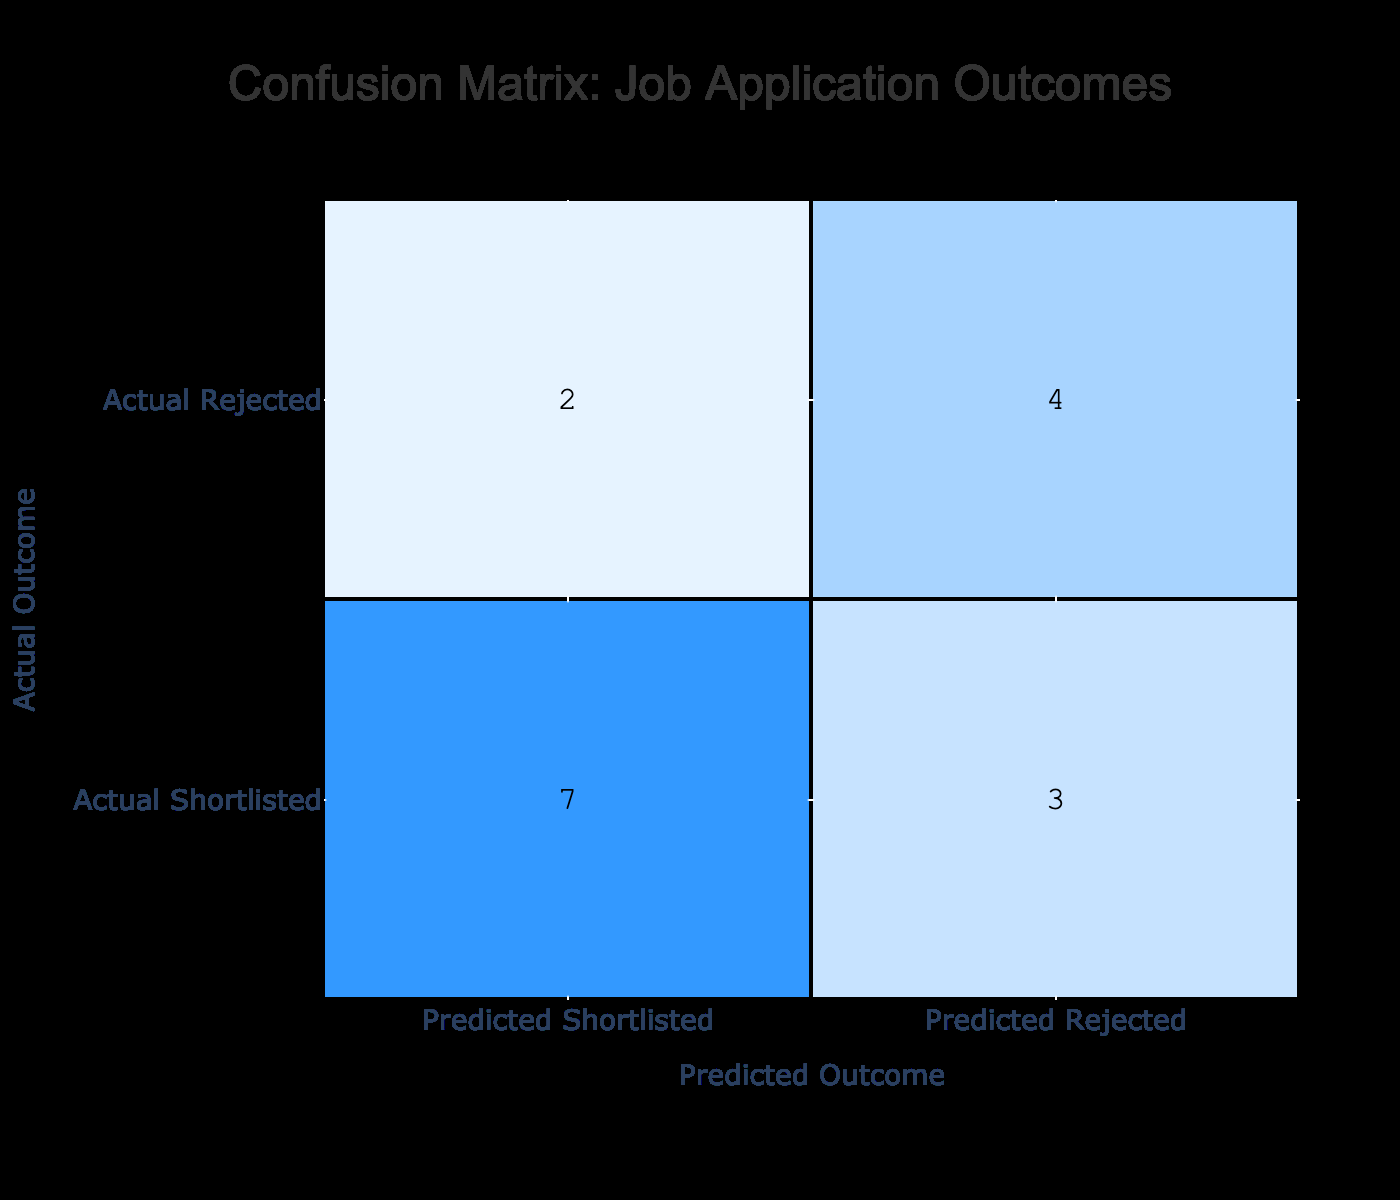What is the number of candidates who were correctly predicted as shortlisted? From the table, there are five candidates whose actual outcome is 'Shortlisted' and the predicted outcome matches as 'Shortlisted'. This can be seen in the first, second, fifth, tenth, thirteenth, and sixteenth positions. Therefore, the total is 6.
Answer: 6 How many candidates were predicted as rejected? The predicted outcome 'Rejected' appears in the table for the positions where candidates were incorrectly classified as 'Rejected' or correctly as 'Rejected'. Counting these occurrences shows that it appears four times in total, which include the fourth, seventh, ninth, thirteenth, and fifteenth positions.
Answer: 7 What is the total number of candidates who actually were shortlisted? By counting the occurrences of 'Shortlisted' in the actual outcome row, we can see it appears 10 times in the entire dataset.
Answer: 10 Were there more candidates correctly rejected or correctly shortlisted? The correctly rejected candidates are in the fourth, seventh, and ninth positions which sum up to 3 candidates, while the correctly shortlisted candidates are in the first, second, fifth, tenth, thirteenth, and sixteenth positions which sum up to 6 candidates. Since 6 is greater than 3, more candidates were correctly shortlisted.
Answer: Yes What is the ratio of candidates who were rejected to those who were shortlisted? There are 4 candidates who were rejected, and 10 who were shortlisted. The ratio can be calculated as 4 (rejected) to 10 (shortlisted), simplifying this gives a ratio of 2:5.
Answer: 2:5 How many candidates were actually rejected but predicted as shortlisted? By examining the table, the candidates who were actually 'Rejected' but predicted as 'Shortlisted' can be found in the sixth and fifteenth positions. This gives us a total of 3 candidates in this category.
Answer: 3 What is the overall accuracy of the predictions? To calculate accuracy, we need to find the total number of correct predictions (shortlisted and rejected) versus the total predictions made. The total correct predictions are 6 (correctly shortlisted) + 4 (correctly rejected) = 10. The total candidates are 16. Thus, accuracy = correct predictions (10) / total predictions (16) = 0.625 or 62.5%.
Answer: 62.5% How many candidates were falsely predicted as shortlisted? In the table, the candidates that were truly 'Rejected' but were predicted as 'Shortlisted' are in the sixth and fourteenth positions. Thus, there are 3 such cases.
Answer: 3 What can be determined about the classifier's performance in terms of sensitivity and specificity? Sensitivity is the true positive rate and is calculated as the number of true positives (correctly shortlisted) divided by the total actual positives (actual shortlisted). Here, sensitivity = 6 / 10 = 0.6 or 60%. Specificity is the true negative rate and is calculated as the number of true negatives (correctly rejected) divided by the total actual negatives (actual rejected). Here, specificity = 4 / 6 = 0.67 or 67%. This indicates moderate performance but with areas for improvement, especially in sensitivity.
Answer: 60% sensitivity, 67% specificity 